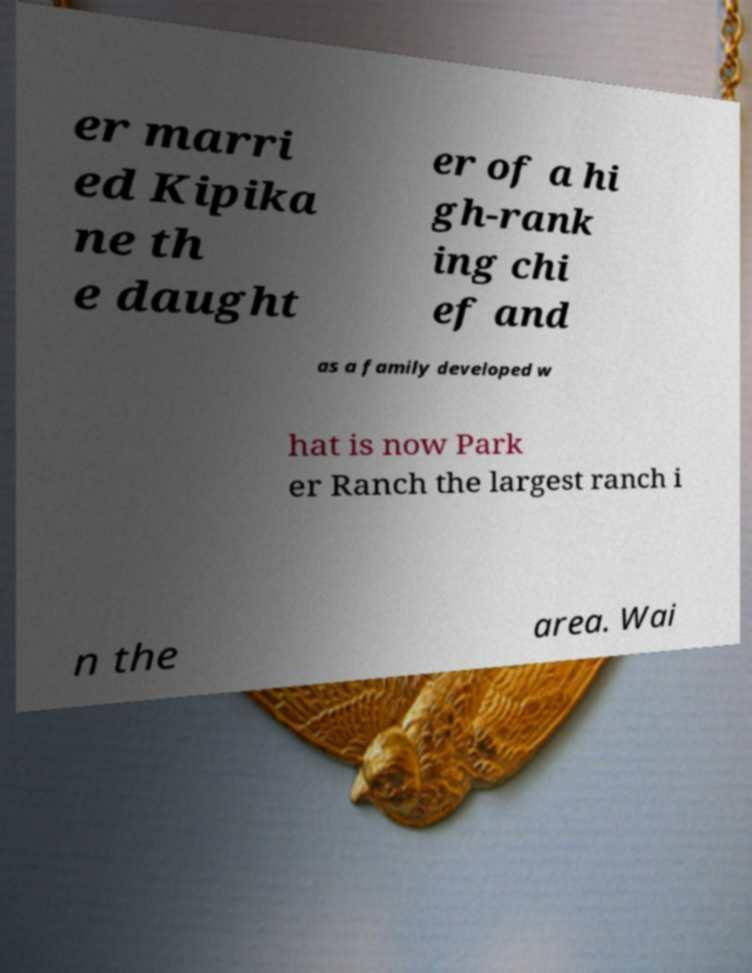Can you accurately transcribe the text from the provided image for me? er marri ed Kipika ne th e daught er of a hi gh-rank ing chi ef and as a family developed w hat is now Park er Ranch the largest ranch i n the area. Wai 